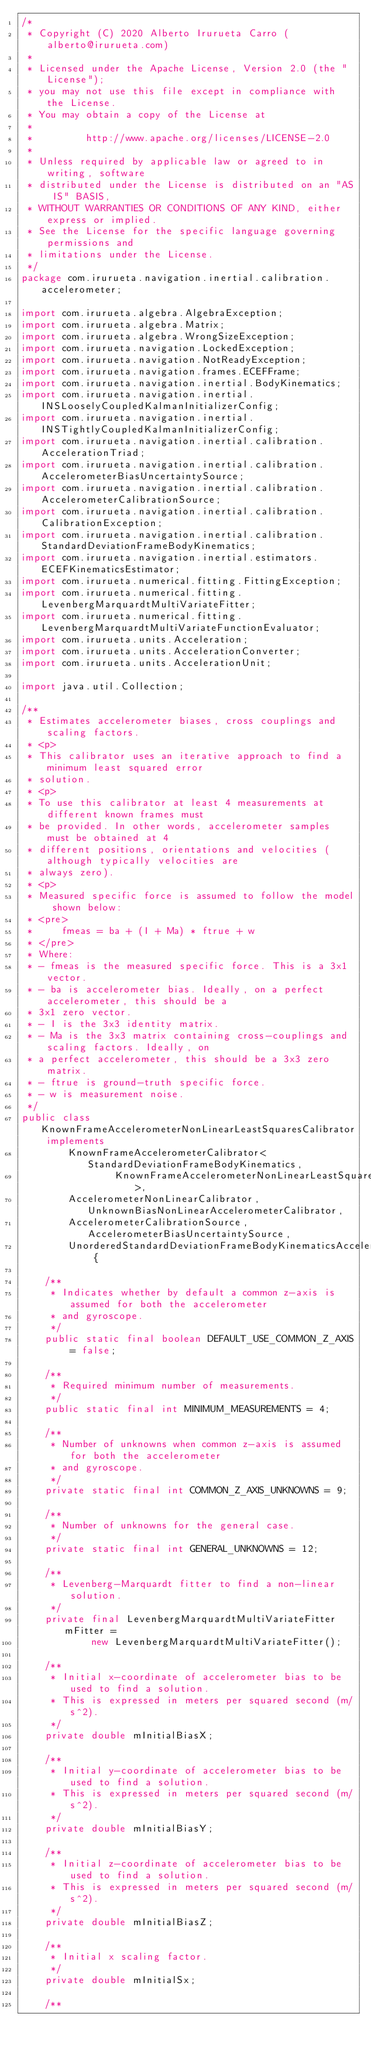<code> <loc_0><loc_0><loc_500><loc_500><_Java_>/*
 * Copyright (C) 2020 Alberto Irurueta Carro (alberto@irurueta.com)
 *
 * Licensed under the Apache License, Version 2.0 (the "License");
 * you may not use this file except in compliance with the License.
 * You may obtain a copy of the License at
 *
 *         http://www.apache.org/licenses/LICENSE-2.0
 *
 * Unless required by applicable law or agreed to in writing, software
 * distributed under the License is distributed on an "AS IS" BASIS,
 * WITHOUT WARRANTIES OR CONDITIONS OF ANY KIND, either express or implied.
 * See the License for the specific language governing permissions and
 * limitations under the License.
 */
package com.irurueta.navigation.inertial.calibration.accelerometer;

import com.irurueta.algebra.AlgebraException;
import com.irurueta.algebra.Matrix;
import com.irurueta.algebra.WrongSizeException;
import com.irurueta.navigation.LockedException;
import com.irurueta.navigation.NotReadyException;
import com.irurueta.navigation.frames.ECEFFrame;
import com.irurueta.navigation.inertial.BodyKinematics;
import com.irurueta.navigation.inertial.INSLooselyCoupledKalmanInitializerConfig;
import com.irurueta.navigation.inertial.INSTightlyCoupledKalmanInitializerConfig;
import com.irurueta.navigation.inertial.calibration.AccelerationTriad;
import com.irurueta.navigation.inertial.calibration.AccelerometerBiasUncertaintySource;
import com.irurueta.navigation.inertial.calibration.AccelerometerCalibrationSource;
import com.irurueta.navigation.inertial.calibration.CalibrationException;
import com.irurueta.navigation.inertial.calibration.StandardDeviationFrameBodyKinematics;
import com.irurueta.navigation.inertial.estimators.ECEFKinematicsEstimator;
import com.irurueta.numerical.fitting.FittingException;
import com.irurueta.numerical.fitting.LevenbergMarquardtMultiVariateFitter;
import com.irurueta.numerical.fitting.LevenbergMarquardtMultiVariateFunctionEvaluator;
import com.irurueta.units.Acceleration;
import com.irurueta.units.AccelerationConverter;
import com.irurueta.units.AccelerationUnit;

import java.util.Collection;

/**
 * Estimates accelerometer biases, cross couplings and scaling factors.
 * <p>
 * This calibrator uses an iterative approach to find a minimum least squared error
 * solution.
 * <p>
 * To use this calibrator at least 4 measurements at different known frames must
 * be provided. In other words, accelerometer samples must be obtained at 4
 * different positions, orientations and velocities (although typically velocities are
 * always zero).
 * <p>
 * Measured specific force is assumed to follow the model shown below:
 * <pre>
 *     fmeas = ba + (I + Ma) * ftrue + w
 * </pre>
 * Where:
 * - fmeas is the measured specific force. This is a 3x1 vector.
 * - ba is accelerometer bias. Ideally, on a perfect accelerometer, this should be a
 * 3x1 zero vector.
 * - I is the 3x3 identity matrix.
 * - Ma is the 3x3 matrix containing cross-couplings and scaling factors. Ideally, on
 * a perfect accelerometer, this should be a 3x3 zero matrix.
 * - ftrue is ground-truth specific force.
 * - w is measurement noise.
 */
public class KnownFrameAccelerometerNonLinearLeastSquaresCalibrator implements
        KnownFrameAccelerometerCalibrator<StandardDeviationFrameBodyKinematics,
                KnownFrameAccelerometerNonLinearLeastSquaresCalibratorListener>,
        AccelerometerNonLinearCalibrator, UnknownBiasNonLinearAccelerometerCalibrator,
        AccelerometerCalibrationSource, AccelerometerBiasUncertaintySource,
        UnorderedStandardDeviationFrameBodyKinematicsAccelerometerCalibrator {

    /**
     * Indicates whether by default a common z-axis is assumed for both the accelerometer
     * and gyroscope.
     */
    public static final boolean DEFAULT_USE_COMMON_Z_AXIS = false;

    /**
     * Required minimum number of measurements.
     */
    public static final int MINIMUM_MEASUREMENTS = 4;

    /**
     * Number of unknowns when common z-axis is assumed for both the accelerometer
     * and gyroscope.
     */
    private static final int COMMON_Z_AXIS_UNKNOWNS = 9;

    /**
     * Number of unknowns for the general case.
     */
    private static final int GENERAL_UNKNOWNS = 12;

    /**
     * Levenberg-Marquardt fitter to find a non-linear solution.
     */
    private final LevenbergMarquardtMultiVariateFitter mFitter =
            new LevenbergMarquardtMultiVariateFitter();

    /**
     * Initial x-coordinate of accelerometer bias to be used to find a solution.
     * This is expressed in meters per squared second (m/s^2).
     */
    private double mInitialBiasX;

    /**
     * Initial y-coordinate of accelerometer bias to be used to find a solution.
     * This is expressed in meters per squared second (m/s^2).
     */
    private double mInitialBiasY;

    /**
     * Initial z-coordinate of accelerometer bias to be used to find a solution.
     * This is expressed in meters per squared second (m/s^2).
     */
    private double mInitialBiasZ;

    /**
     * Initial x scaling factor.
     */
    private double mInitialSx;

    /**</code> 